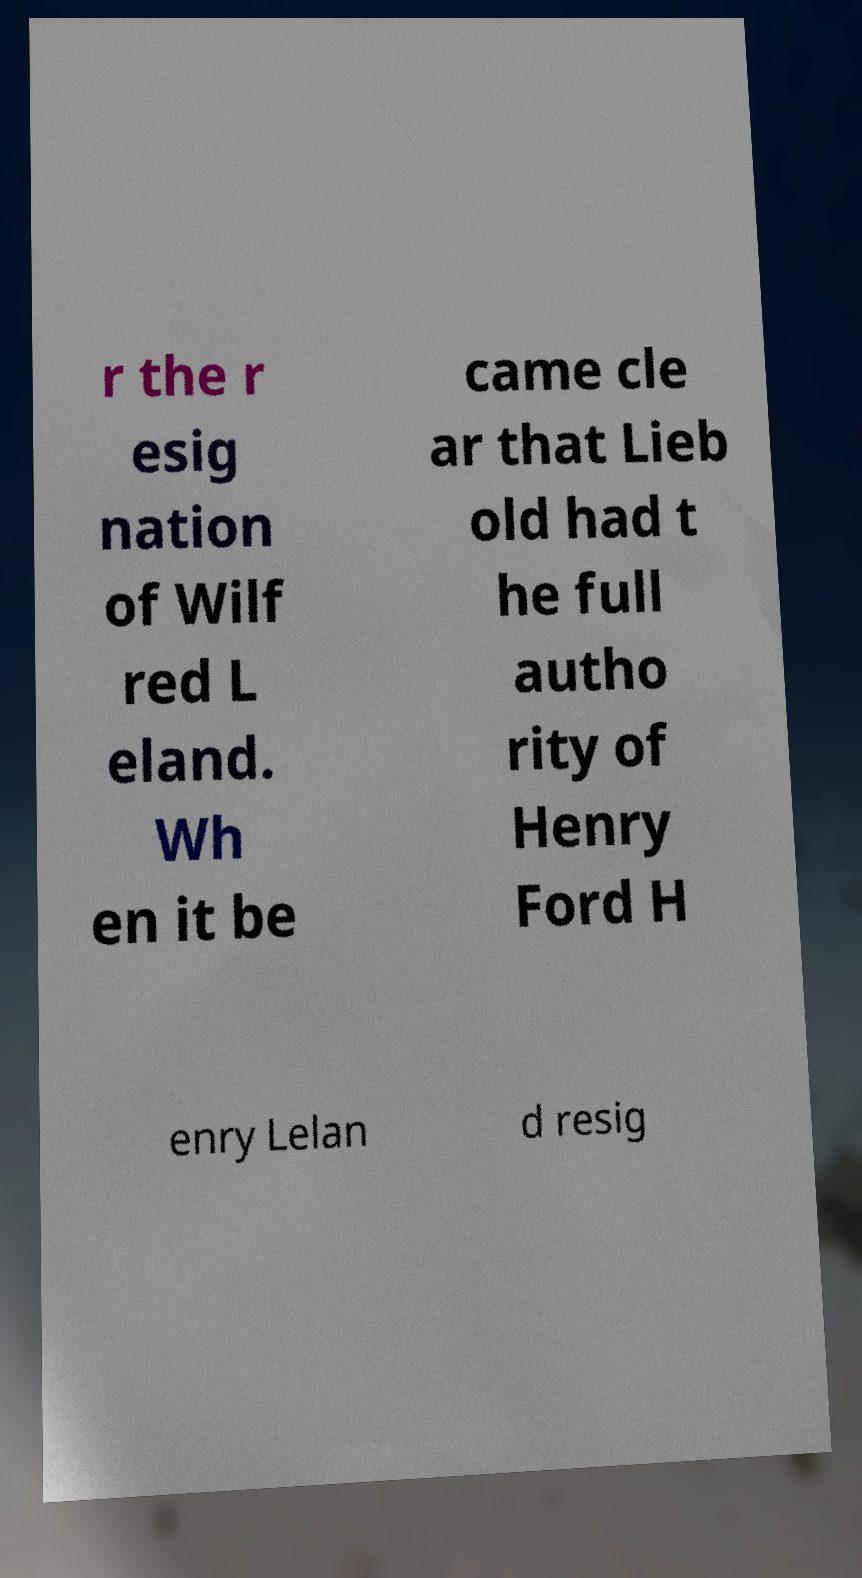Could you assist in decoding the text presented in this image and type it out clearly? r the r esig nation of Wilf red L eland. Wh en it be came cle ar that Lieb old had t he full autho rity of Henry Ford H enry Lelan d resig 